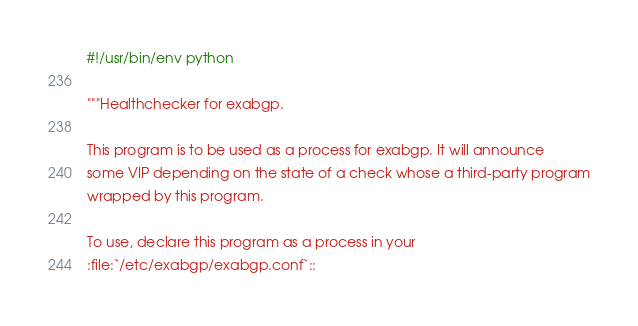Convert code to text. <code><loc_0><loc_0><loc_500><loc_500><_Python_>#!/usr/bin/env python

"""Healthchecker for exabgp.

This program is to be used as a process for exabgp. It will announce
some VIP depending on the state of a check whose a third-party program
wrapped by this program.

To use, declare this program as a process in your
:file:`/etc/exabgp/exabgp.conf`::
</code> 